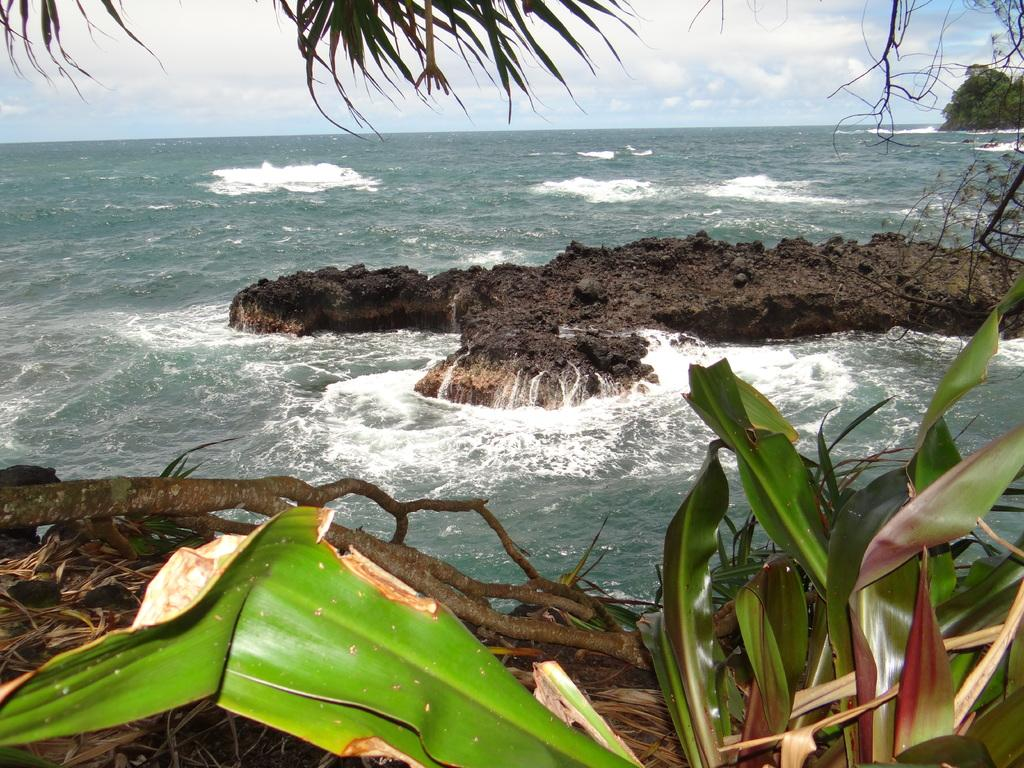What type of vegetation is in the front of the image? There are plants in the front of the image. What is located in the center of the image? There is soil in the center of the image. What can be seen in the background of the image? There is an ocean and trees in the background of the image. What is the condition of the sky in the image? The sky is cloudy in the image. How many potatoes are being divided among the cast in the image? There are no potatoes or cast members present in the image. What type of potato is being used to create the division in the image? There is no potato or division present in the image. 